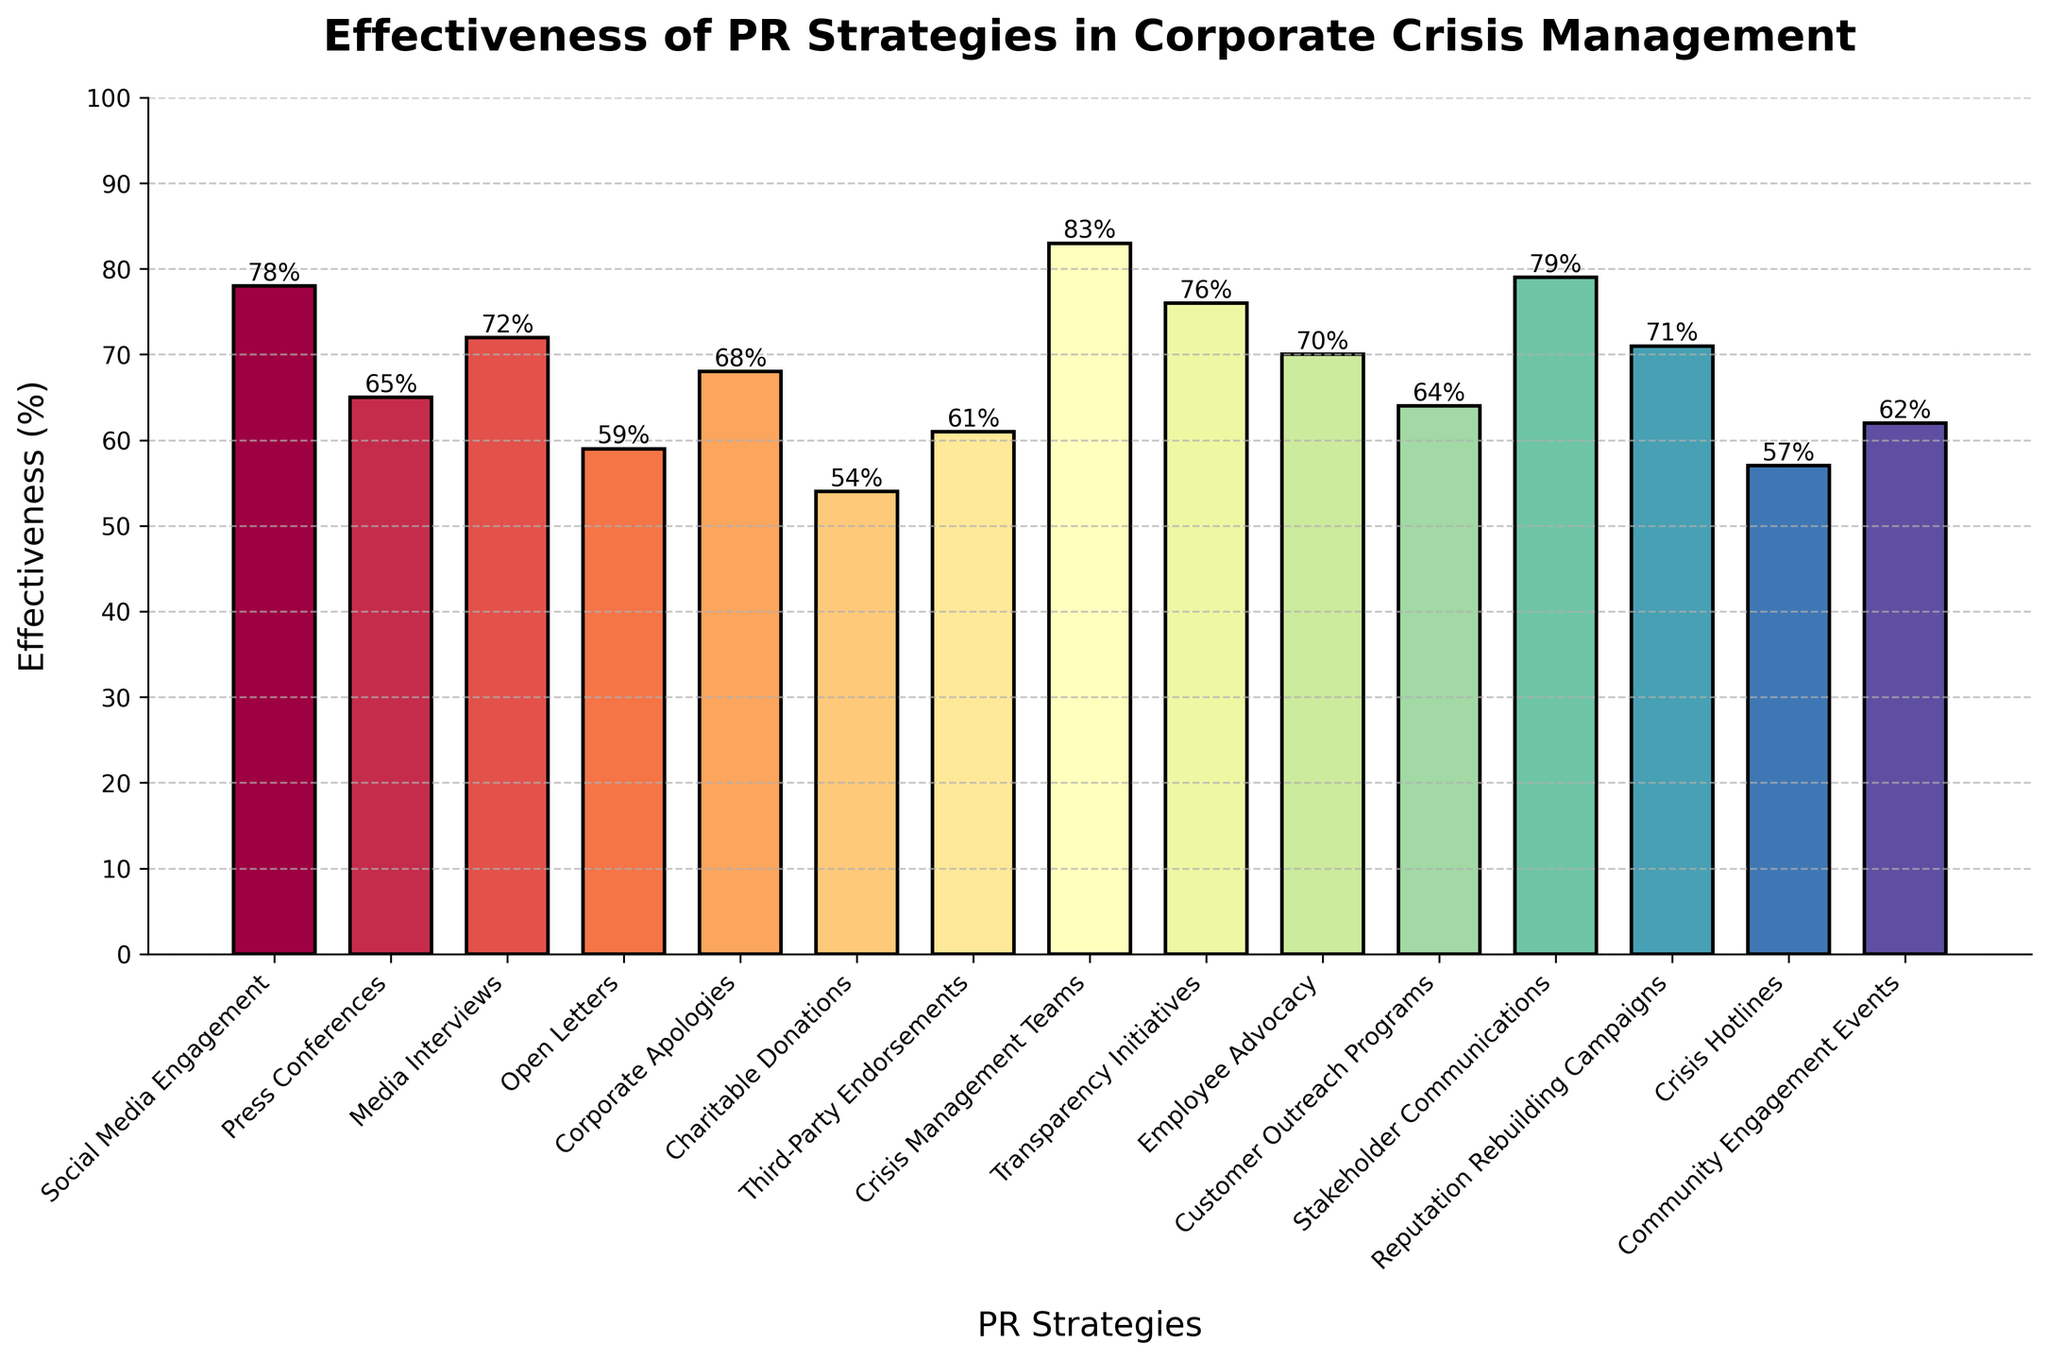Which PR strategy has the highest effectiveness according to the chart? By observing the chart, the bar representing the "Crisis Management Teams" strategy is the tallest, indicating the highest effectiveness.
Answer: Crisis Management Teams What is the difference in effectiveness between Social Media Engagement and Corporate Apologies? From the chart, Social Media Engagement has an effectiveness of 78%, and Corporate Apologies have 68%. By subtracting 68 from 78, the difference is calculated.
Answer: 10% Which PR strategy is more effective: Media Interviews or Employee Advocacy? Comparing the height of the bars, Media Interviews show an effectiveness of 72%, while Employee Advocacy shows 70%. Media Interviews has a slightly higher effectiveness.
Answer: Media Interviews How many PR strategies have an effectiveness rate of 70% or higher? The strategies with an effectiveness of 70% or higher are Social Media Engagement (78%), Media Interviews (72%), Corporate Apologies (68%), Crisis Management Teams (83%), Transparency Initiatives (76%), Employee Advocacy (70%), Stakeholder Communications (79%), and Reputation Rebuilding Campaigns (71%). Counting these, there are 8 strategies.
Answer: 8 What is the average effectiveness of the strategies "Charitable Donations", "Open Letters", and "Crisis Hotlines"? The effectiveness of Charitable Donations is 54%, Open Letters is 59%, and Crisis Hotlines is 57%. Adding these effectiveness percentages gives (54 + 59 + 57 = 170). Dividing by the number of strategies (3), the average effectiveness is 56.67%.
Answer: 56.67% Which strategy has a lower effectiveness: Customer Outreach Programs or Community Engagement Events? Comparing the bars for these strategies, Customer Outreach Programs has an effectiveness of 64%, while Community Engagement Events has 62%. Therefore, Community Engagement Events have a lower effectiveness.
Answer: Community Engagement Events What is the combined effectiveness of the strategies with effectiveness below 60%? The strategies with effectiveness below 60% are Open Letters (59%), Charitable Donations (54%), Crisis Hotlines (57%), and Community Engagement Events (62%). Adding the percentages (59 + 54 + 57 + 62 = 232), the combined effectiveness is 232%.
Answer: 232% Which PR strategy among "Press Conferences", "Third-Party Endorsements", and "Customer Outreach Programs" ranks highest in effectiveness? The effectiveness of Press Conferences is 65%, Third-Party Endorsements is 61%, and Customer Outreach Programs is 64%. The highest among these is Press Conferences.
Answer: Press Conferences 